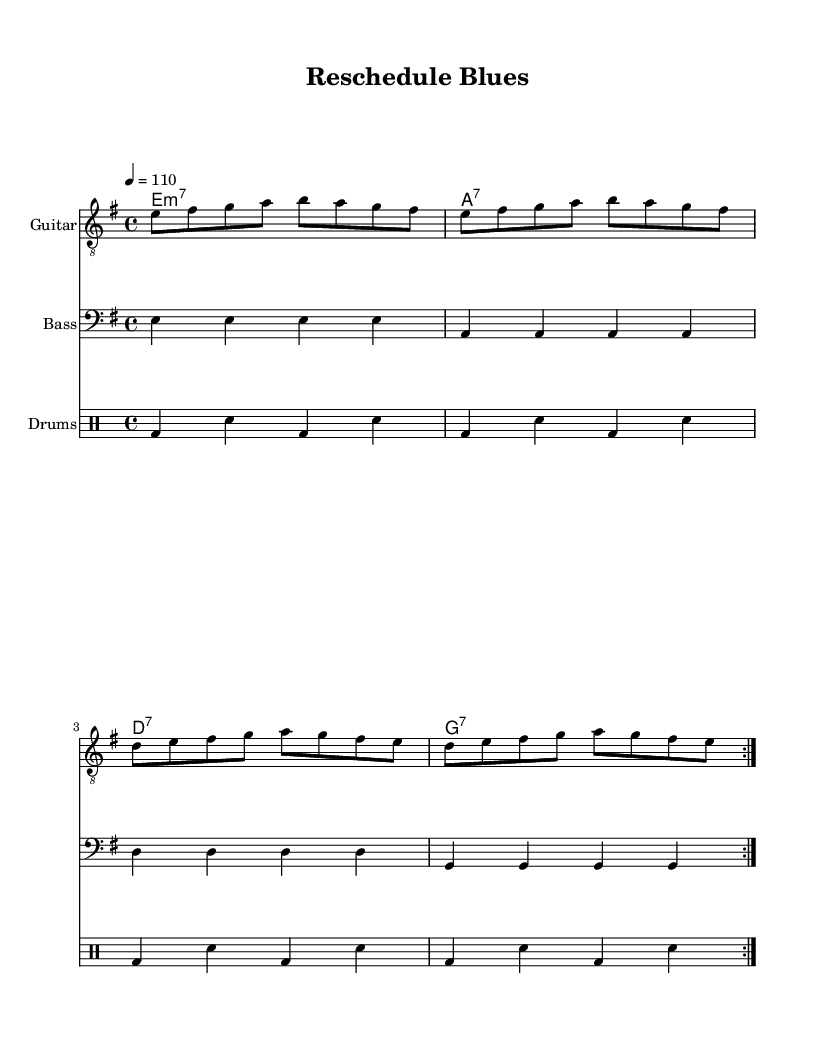What is the key signature of this music? The key signature is E minor, which has one sharp (F#). This can be determined by looking at the global settings in the sheet music where it specifies the key as 'e'.
Answer: E minor What is the time signature of this music? The time signature is 4/4, indicated in the global settings of the sheet music. This means there are four beats in each measure, and the quarter note gets one beat.
Answer: 4/4 What is the tempo marking for this piece? The tempo marking is quarter note equals 110, which indicates that the quarter note will be played at a speed of 110 beats per minute. This is specified in the global settings.
Answer: 110 How many measures are repeated in the guitar part? The guitar part shows a repeat sign, specifically 'volta 2', which indicates that there are two sections of music that are repeated. This can be observed in the 'guitarMusic' section which has repeated measures.
Answer: 2 What instrument uses the clef "treble_8"? The instrument that uses the clef "treble_8" is the Guitar. The clef is specifically indicated in the Staff settings for the guitar part.
Answer: Guitar Which type of song does this music represent? This music represents a "Funky protest song," which is indicated by the title "Reschedule Blues" and the lyrics reflecting frustrations with constant rescheduling. The style aligns with the Funk genre typically characterized by rhythmic expressions of social issues.
Answer: Funky protest song How many different instruments are featured in this score? The score features three different instruments: Guitar, Bass, and Drums. Each instrument is represented in separate staffs within the score layout.
Answer: 3 